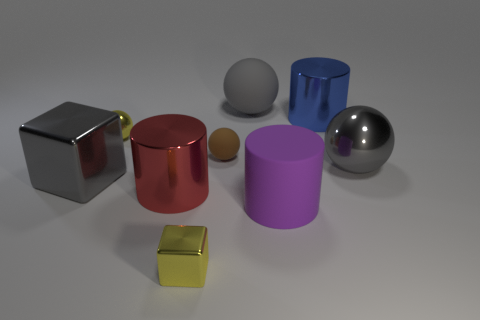What is the shape of the small rubber thing? sphere 